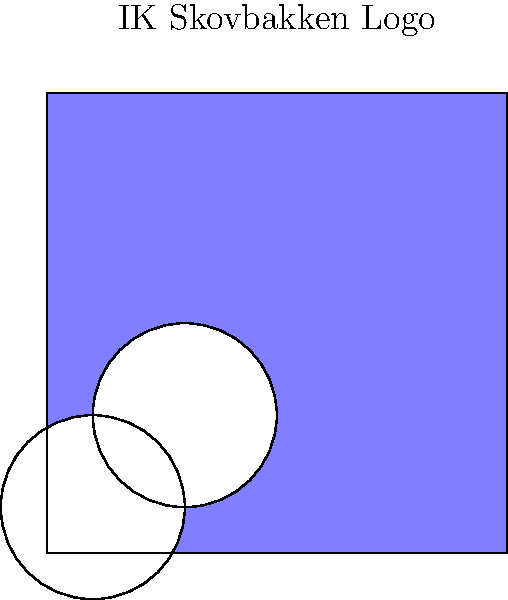Remember our beloved IK Skovbakken team logo? It's a square with two circular holes, just like in the image above. Thinking back to those glorious days, can you determine the Euler characteristic of a surface shaped like our logo? Let's walk through this together, just like we used to analyze our game strategies:

1) First, recall the Euler characteristic formula: $\chi = V - E + F$, where:
   $V$ = number of vertices
   $E$ = number of edges
   $F$ = number of faces

2) For our logo surface:
   - We have 4 vertices (the corners of the square)
   - We have 4 edges (the sides of the square)
   - We have 3 faces (the main square face and the two circular hole faces)

3) Now, let's plug these into our formula:
   $\chi = 4 - 4 + 3 = 3$

4) However, we need to consider that the two circular holes make this surface topologically equivalent to a sphere with two holes.

5) For a sphere, $\chi = 2$. Each hole reduces the Euler characteristic by 1.

6) Therefore, the final Euler characteristic is:
   $\chi = 2 - 2 = 0$

This result brings back memories of how our team always found balance, just like this logo's Euler characteristic!
Answer: 0 